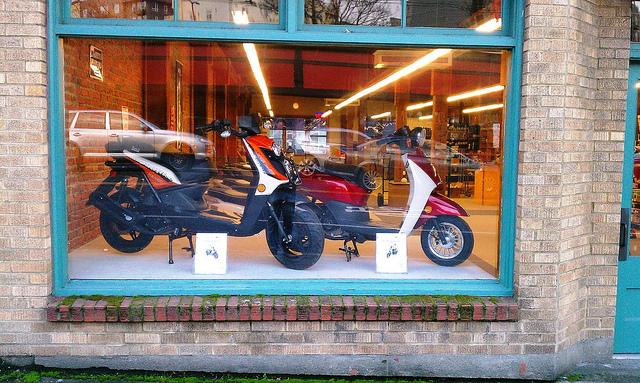How many people can ride this vehicle?
Keep it brief. 2. What object can clearly be seen reflected in the glass window?
Short answer required. Car. Is there moss growing on the bricks?
Keep it brief. Yes. 